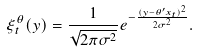Convert formula to latex. <formula><loc_0><loc_0><loc_500><loc_500>\xi _ { t } ^ { \theta } ( y ) = \frac { 1 } { \sqrt { 2 \pi \sigma ^ { 2 } } } e ^ { - \frac { ( y - \theta ^ { \prime } x _ { t } ) ^ { 2 } } { 2 \sigma ^ { 2 } } } .</formula> 